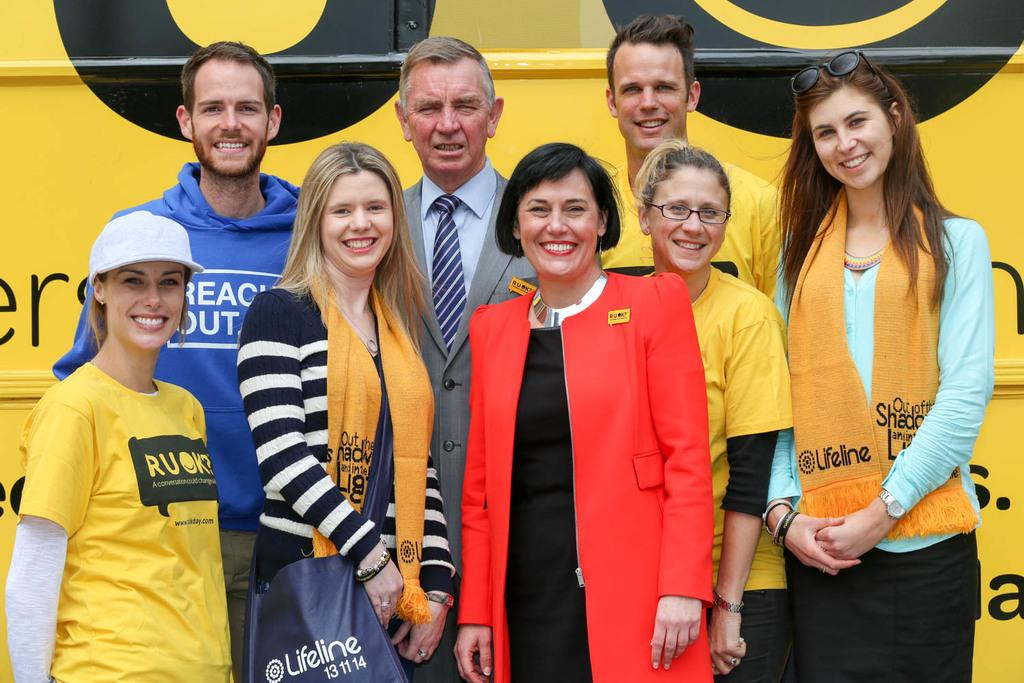<image>
Share a concise interpretation of the image provided. A group of people supporting Ru Ok, a conversation could change all. 